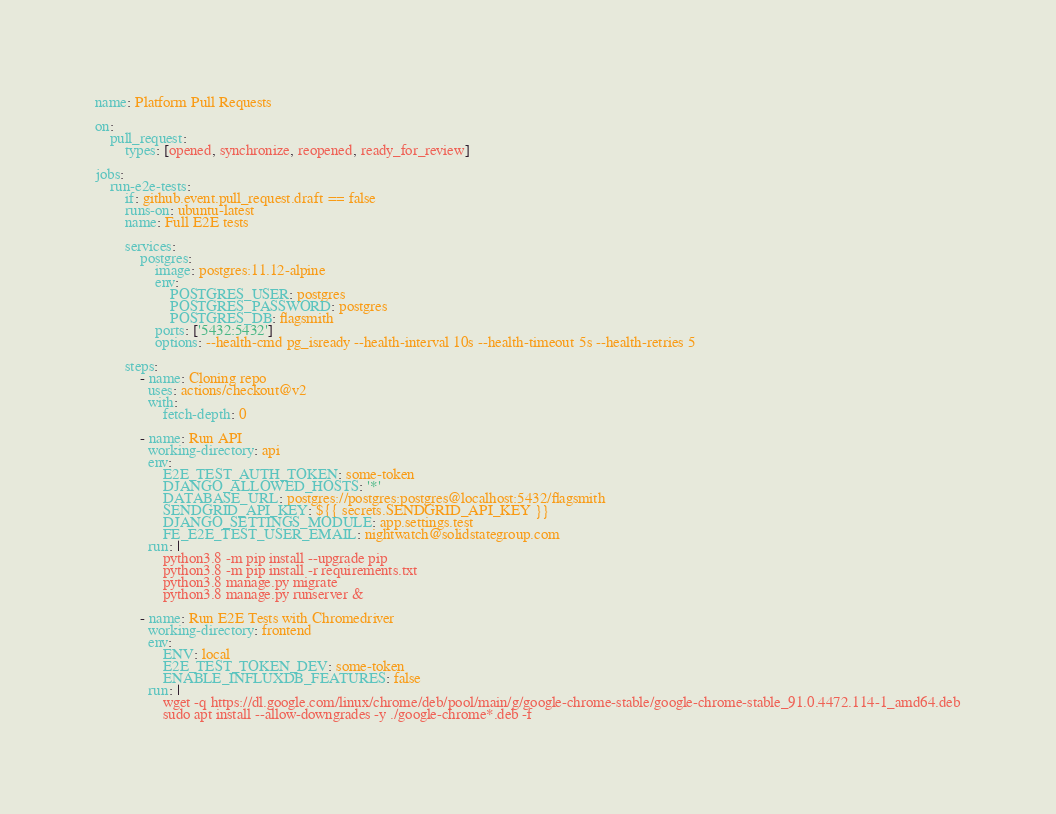Convert code to text. <code><loc_0><loc_0><loc_500><loc_500><_YAML_>name: Platform Pull Requests

on:
    pull_request:
        types: [opened, synchronize, reopened, ready_for_review]

jobs:
    run-e2e-tests:
        if: github.event.pull_request.draft == false
        runs-on: ubuntu-latest
        name: Full E2E tests

        services:
            postgres:
                image: postgres:11.12-alpine
                env:
                    POSTGRES_USER: postgres
                    POSTGRES_PASSWORD: postgres
                    POSTGRES_DB: flagsmith
                ports: ['5432:5432']
                options: --health-cmd pg_isready --health-interval 10s --health-timeout 5s --health-retries 5

        steps:
            - name: Cloning repo
              uses: actions/checkout@v2
              with:
                  fetch-depth: 0

            - name: Run API
              working-directory: api
              env:
                  E2E_TEST_AUTH_TOKEN: some-token
                  DJANGO_ALLOWED_HOSTS: '*'
                  DATABASE_URL: postgres://postgres:postgres@localhost:5432/flagsmith
                  SENDGRID_API_KEY: ${{ secrets.SENDGRID_API_KEY }}
                  DJANGO_SETTINGS_MODULE: app.settings.test
                  FE_E2E_TEST_USER_EMAIL: nightwatch@solidstategroup.com
              run: |
                  python3.8 -m pip install --upgrade pip
                  python3.8 -m pip install -r requirements.txt
                  python3.8 manage.py migrate
                  python3.8 manage.py runserver &

            - name: Run E2E Tests with Chromedriver
              working-directory: frontend
              env:
                  ENV: local
                  E2E_TEST_TOKEN_DEV: some-token
                  ENABLE_INFLUXDB_FEATURES: false
              run: |
                  wget -q https://dl.google.com/linux/chrome/deb/pool/main/g/google-chrome-stable/google-chrome-stable_91.0.4472.114-1_amd64.deb
                  sudo apt install --allow-downgrades -y ./google-chrome*.deb -f </code> 